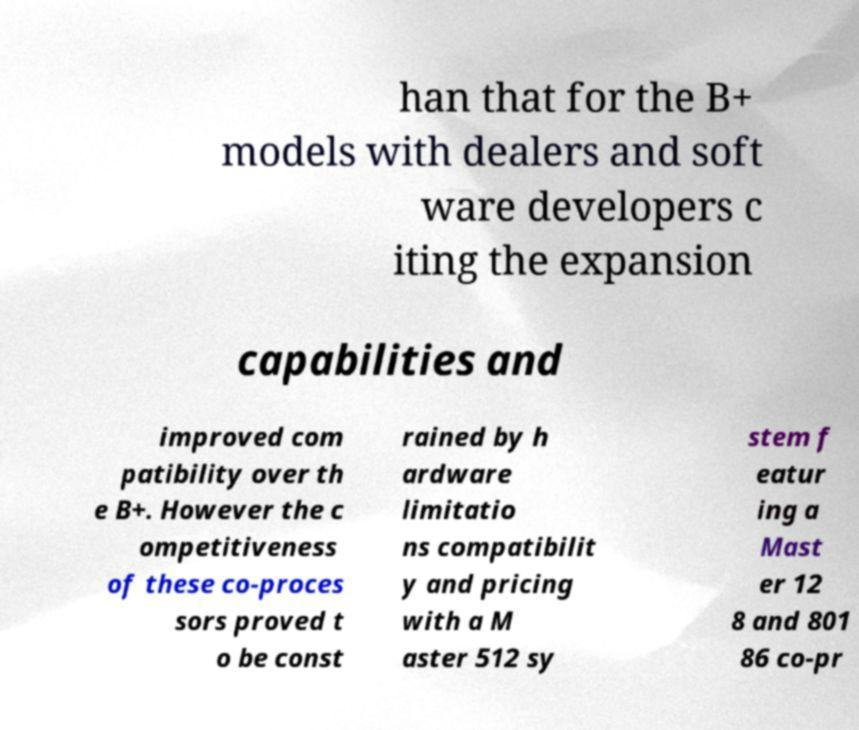Could you extract and type out the text from this image? han that for the B+ models with dealers and soft ware developers c iting the expansion capabilities and improved com patibility over th e B+. However the c ompetitiveness of these co-proces sors proved t o be const rained by h ardware limitatio ns compatibilit y and pricing with a M aster 512 sy stem f eatur ing a Mast er 12 8 and 801 86 co-pr 